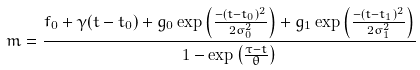Convert formula to latex. <formula><loc_0><loc_0><loc_500><loc_500>m = \frac { f _ { 0 } + \gamma ( t - t _ { 0 } ) + g _ { 0 } \exp \left ( { \frac { - ( t - t _ { 0 } ) ^ { 2 } } { 2 \sigma _ { 0 } ^ { 2 } } } \right ) + g _ { 1 } \exp \left ( { \frac { - ( t - t _ { 1 } ) ^ { 2 } } { 2 \sigma _ { 1 } ^ { 2 } } } \right ) } { 1 - \exp \left ( { \frac { \tau - t } { \theta } } \right ) }</formula> 